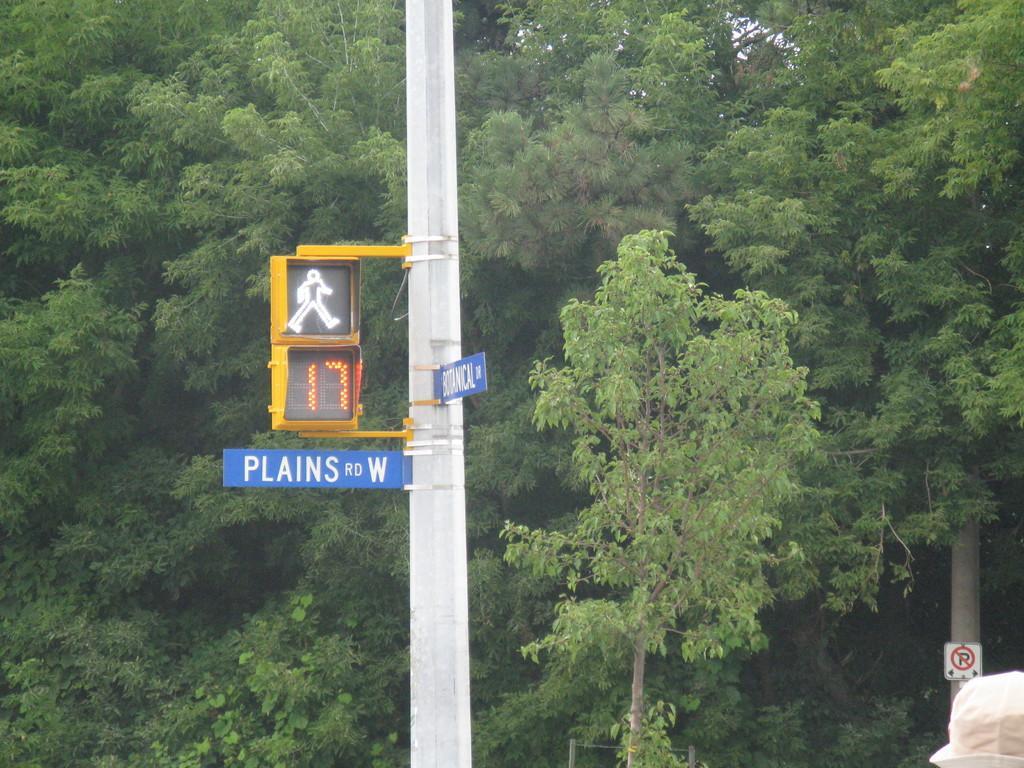Can you describe this image briefly? In this picture we can see a name board and a traffic signal attached to a pole, signboard, cap and in the background we can see trees. 